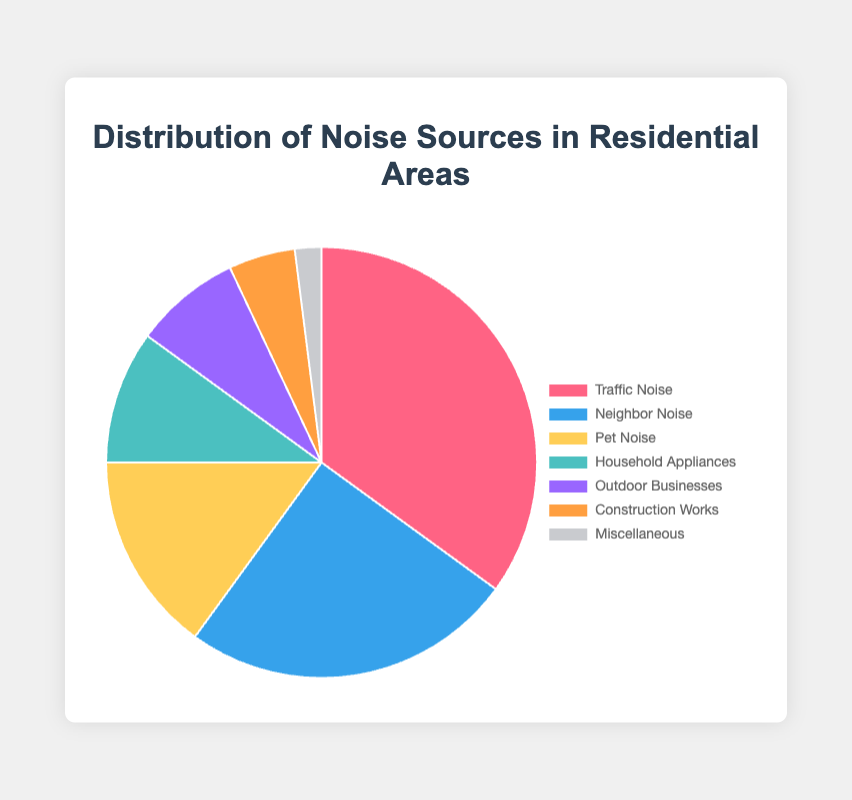What is the most common source of noise in residential areas? The pie chart shows that Traffic Noise has the highest percentage at 35%.
Answer: Traffic Noise What is the combined percentage of noise caused by neighbors and pets? Add the percentages of Neighbor Noise (25%) and Pet Noise (15%) to find the total. 25% + 15% = 40%.
Answer: 40% Which noise source is less prevalent: Household Appliances or Outdoor Businesses? Compare the percentages for Household Appliances (10%) and Outdoor Businesses (8%). Outdoor Businesses is less prevalent because 8% < 10%.
Answer: Outdoor Businesses What is the difference in percentage between the most and least common noise sources? The most common source is Traffic Noise (35%) and the least common is Miscellaneous (2%). Subtract the smallest percentage from the largest: 35% - 2% = 33%.
Answer: 33% What sources contribute the least to noise pollution, totaling less than 10% each? Identify sources with percentages less than 10%. Outdoor Businesses (8%), Construction Works (5%), and Miscellaneous (2%) all meet this criterion.
Answer: Outdoor Businesses, Construction Works, Miscellaneous What is the average percentage of noise caused by Pet Noise, Household Appliances, and Construction Works? Sum the percentages of Pet Noise (15%), Household Appliances (10%), and Construction Works (5%), then divide by 3. (15% + 10% + 5%) / 3 ≈ 10%.
Answer: 10% How many sources have a higher percentage than Pet Noise? Pet Noise is 15%. The sources with higher percentages are Traffic Noise (35%) and Neighbor Noise (25%). There are 2 sources.
Answer: 2 Which noise source represented by the pie chart uses a blue visual color? In the pie chart, the label 'Neighbor Noise' is represented with the color blue within the provided data.
Answer: Neighbor Noise 